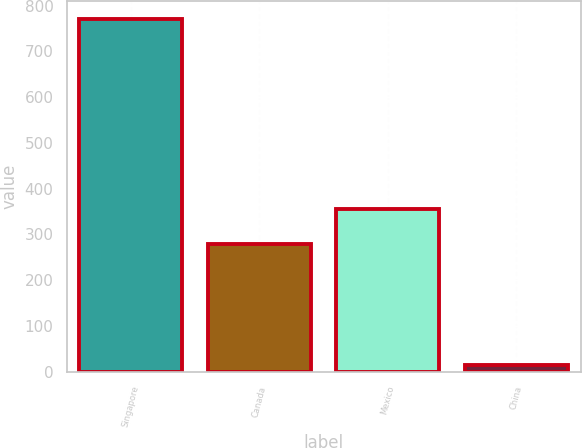Convert chart. <chart><loc_0><loc_0><loc_500><loc_500><bar_chart><fcel>Singapore<fcel>Canada<fcel>Mexico<fcel>China<nl><fcel>771<fcel>279<fcel>354.7<fcel>14<nl></chart> 